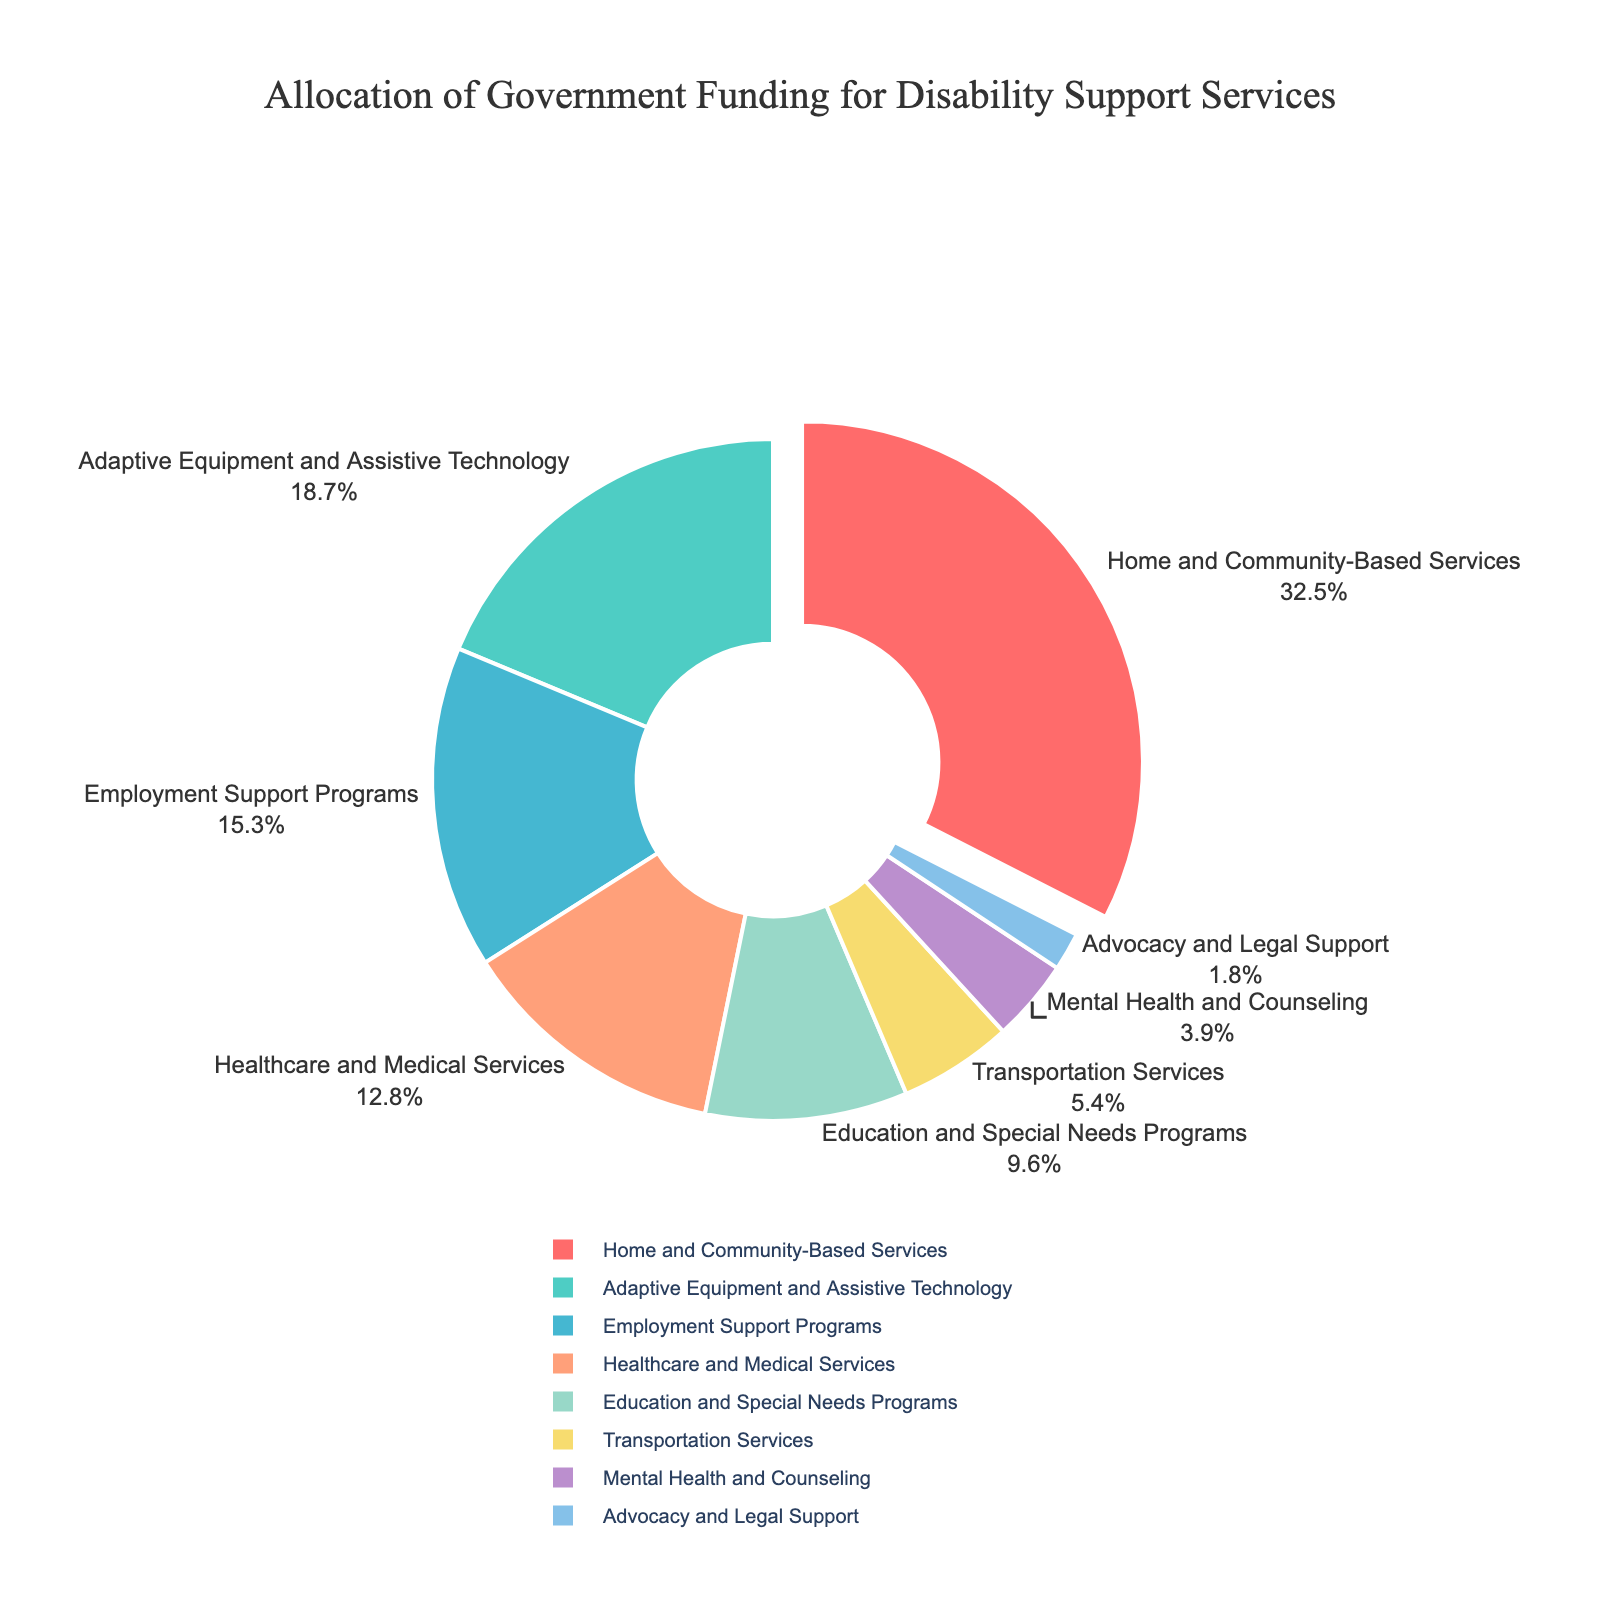what is the category with the highest allocation of funding? The category with the highest percentage of the pie chart is pulled out slightly from the rest. By looking at the chart, we can see that "Home and Community-Based Services" has the largest portion of the pie, which is 32.5%.
Answer: Home and Community-Based Services what is the combined percentage of funding for Adaptive Equipment and Assistive Technology, and Education and Special Needs Programs? To find the answer, sum the percentages of "Adaptive Equipment and Assistive Technology" (18.7%) and "Education and Special Needs Programs" (9.6%). Thus, 18.7 + 9.6 = 28.3%.
Answer: 28.3% which category receives less funding: Mental Health and Counseling or Transportation Services? Compare the percentages of the two categories: "Mental Health and Counseling" has 3.9% while "Transportation Services" has 5.4%. Since 3.9 is less than 5.4, "Mental Health and Counseling" receives less funding.
Answer: Mental Health and Counseling how much more funding does Home and Community-Based Services receive compared to Transportation Services? Subtract the percentage allocated to "Transportation Services" (5.4%) from that allocated to "Home and Community-Based Services" (32.5%). Thus, 32.5 - 5.4 = 27.1%.
Answer: 27.1% which categories have a funding allocation less than 10%? By checking the pie chart, the categories with less than 10% allocation are "Transportation Services" (5.4%), "Mental Health and Counseling" (3.9%), and "Advocacy and Legal Support" (1.8%).
Answer: Transportation Services, Mental Health and Counseling, Advocacy and Legal Support what is the total percentage allocation for Employment Support Programs and Healthcare and Medical Services? Sum the percentages allocated to "Employment Support Programs" (15.3%) and "Healthcare and Medical Services" (12.8%). Thus, 15.3 + 12.8 = 28.1%.
Answer: 28.1% which category has a funding representation in blue color? Reviewing the colors in the pie chart, "Adaptive Equipment and Assistive Technology" is represented by the blue color.
Answer: Adaptive Equipment and Assistive Technology 